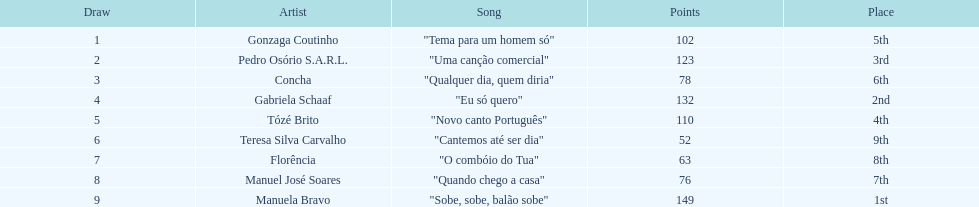Who was the last draw? Manuela Bravo. 